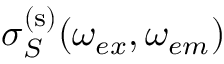<formula> <loc_0><loc_0><loc_500><loc_500>\sigma _ { S } ^ { ( s ) } ( \omega _ { e x } , \omega _ { e m } )</formula> 